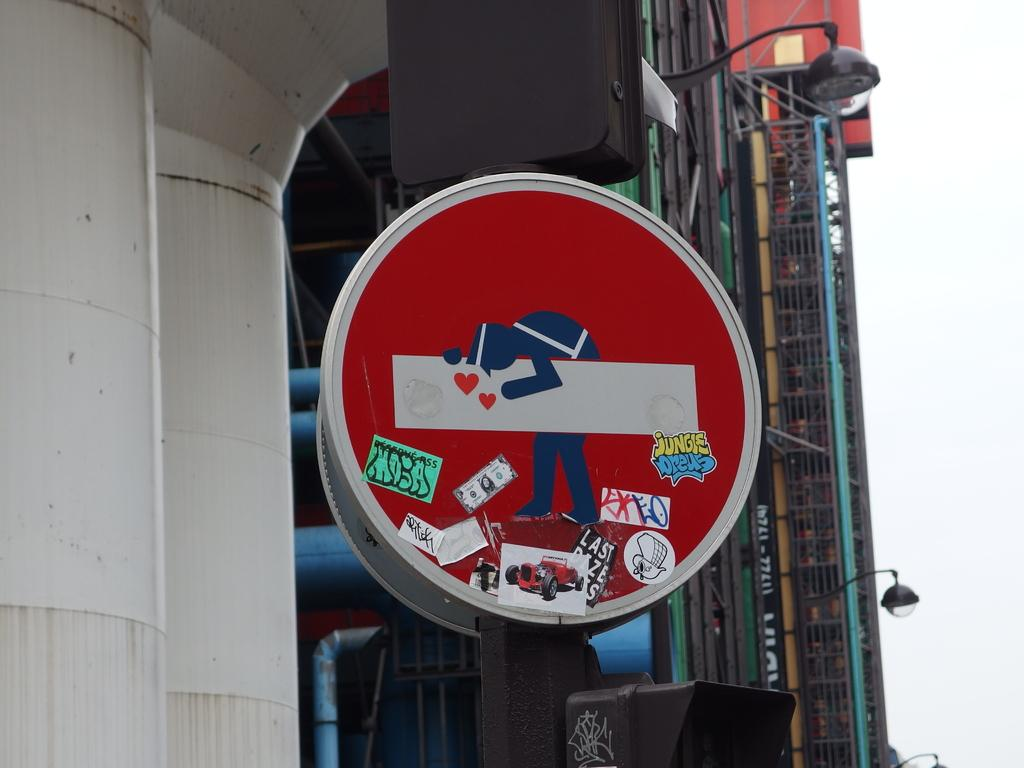<image>
Offer a succinct explanation of the picture presented. A round red sign has an image carrying something with various stickers covering the bottom of the sign. 